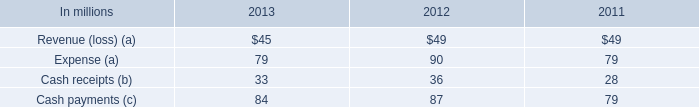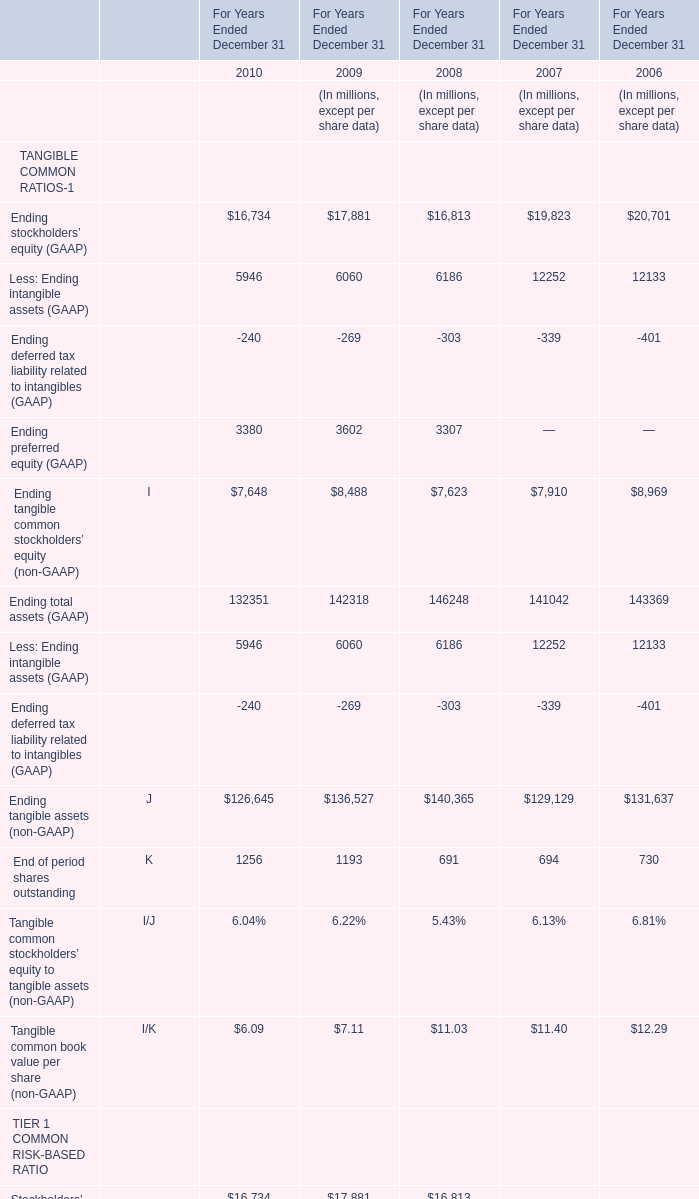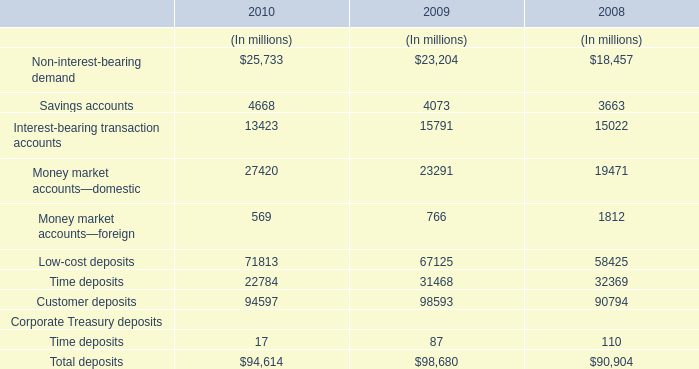What is the total value of Ending stockholders’ equity (GAAP)Less: Ending intangible assets (GAAP) Ending deferred tax liability related to intangibles (GAAP)Ending preferred equity (GAAP) in 2010? (in million) 
Computations: (((16734 + 5946) - 240) + 3380)
Answer: 25820.0. 